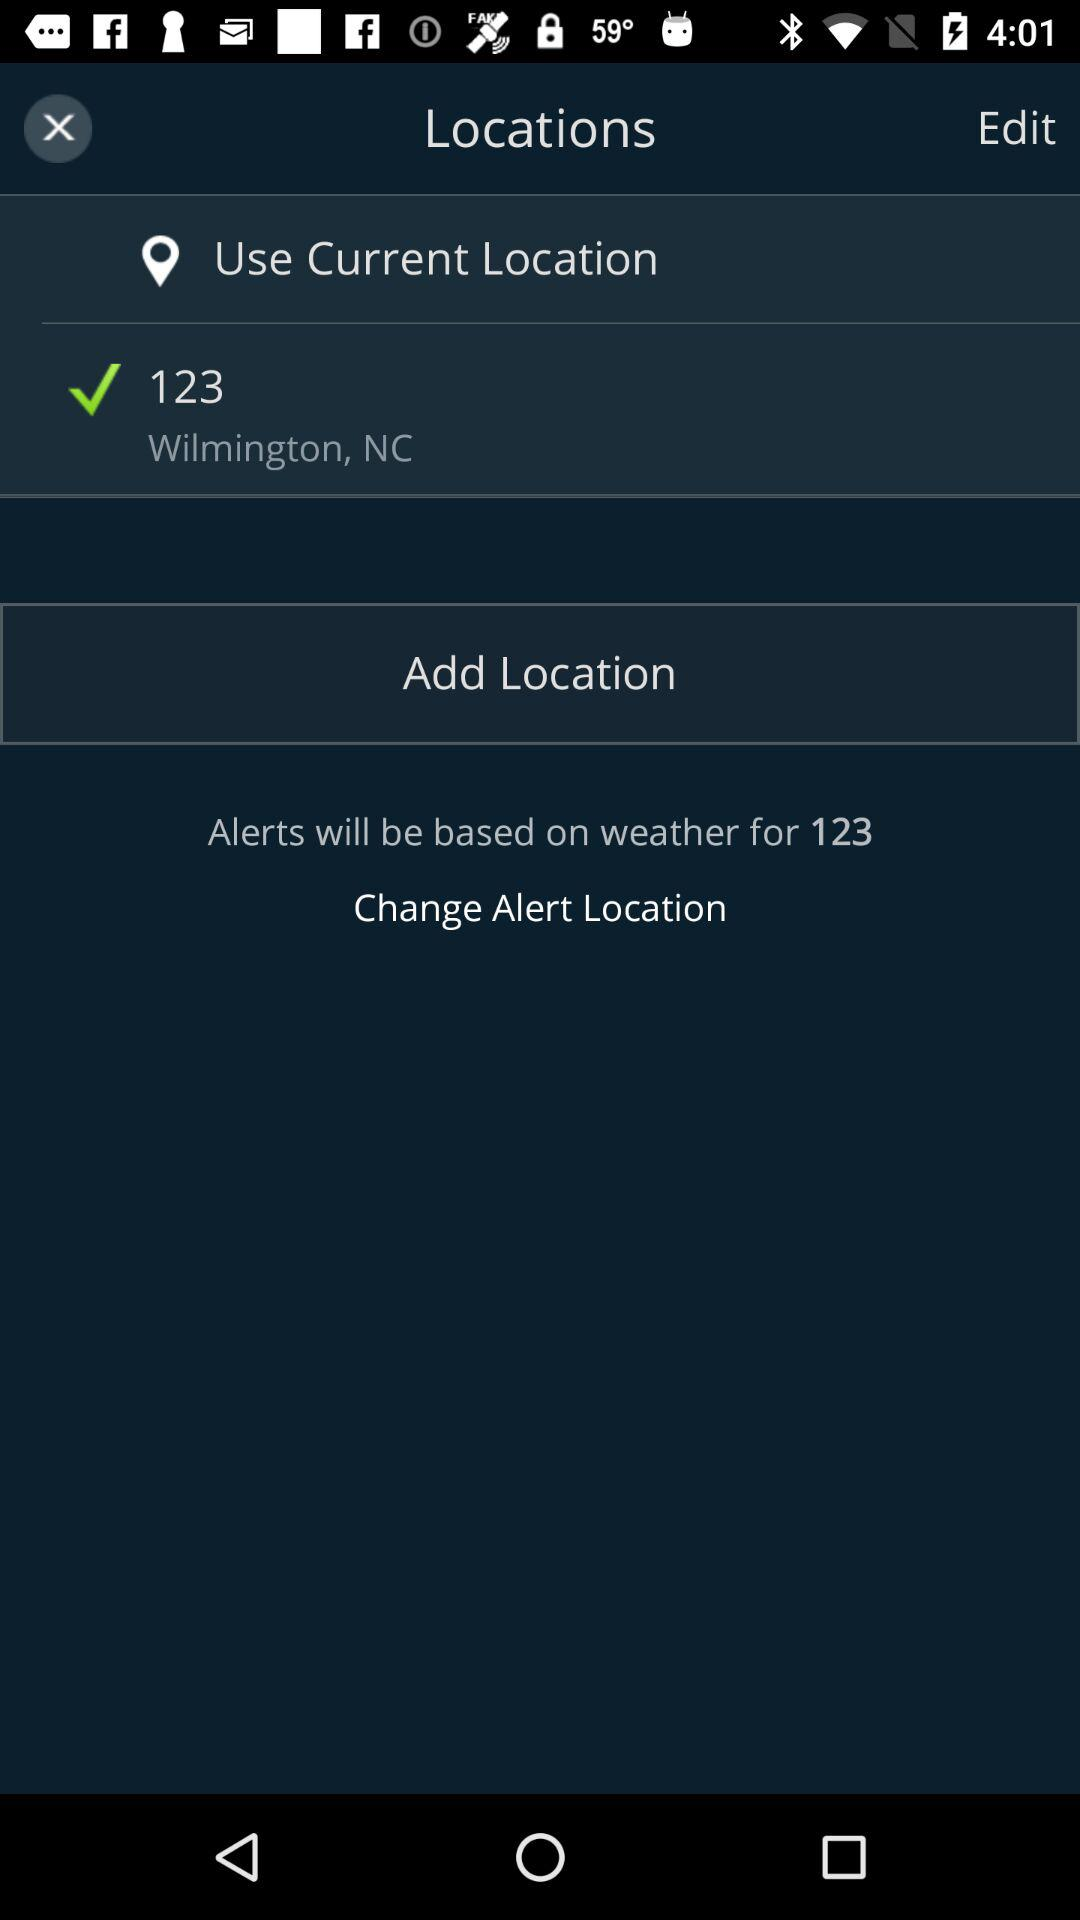What is the current location? The current location is 123 Wilmington, NC. 